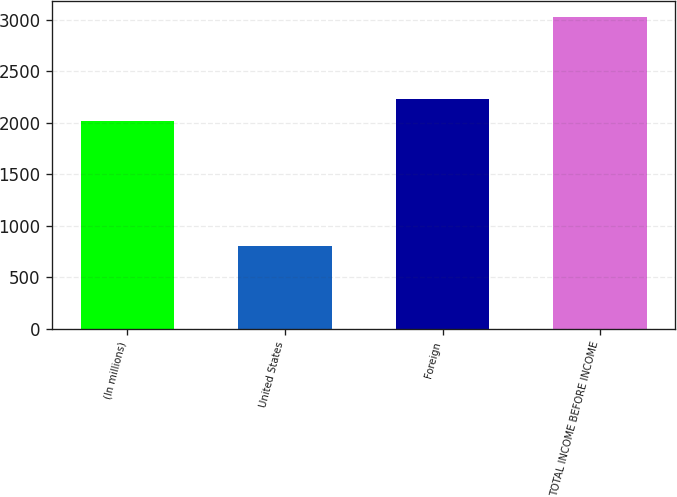Convert chart. <chart><loc_0><loc_0><loc_500><loc_500><bar_chart><fcel>(In millions)<fcel>United States<fcel>Foreign<fcel>TOTAL INCOME BEFORE INCOME<nl><fcel>2012<fcel>804<fcel>2234.1<fcel>3025<nl></chart> 